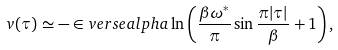<formula> <loc_0><loc_0><loc_500><loc_500>v ( \tau ) \simeq - \in v e r s e a l p h a \ln \left ( \frac { \beta \omega ^ { * } } { \pi } \sin \frac { \pi | \tau | } { \beta } + 1 \right ) ,</formula> 